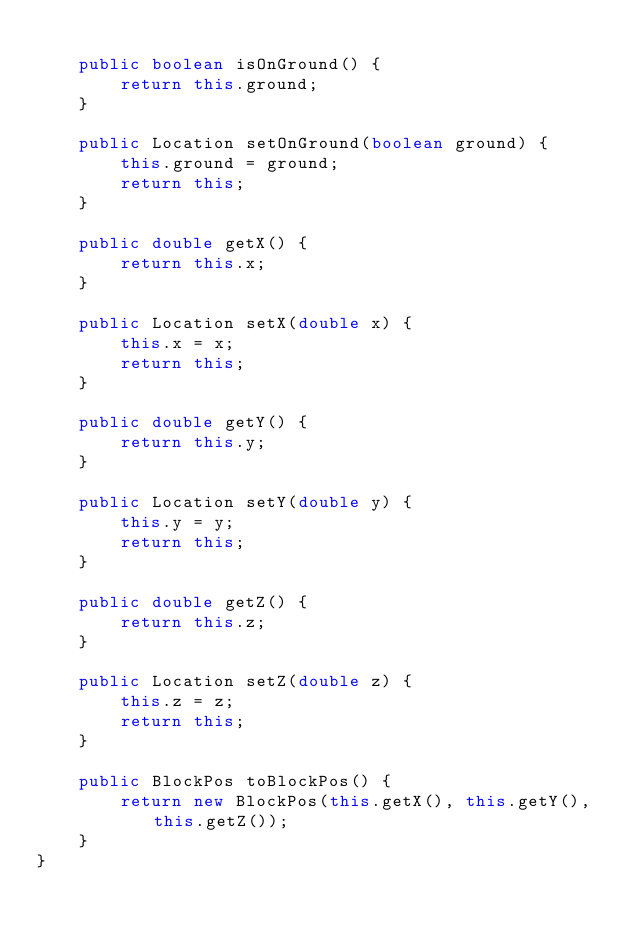<code> <loc_0><loc_0><loc_500><loc_500><_Java_>
    public boolean isOnGround() {
        return this.ground;
    }

    public Location setOnGround(boolean ground) {
        this.ground = ground;
        return this;
    }

    public double getX() {
        return this.x;
    }

    public Location setX(double x) {
        this.x = x;
        return this;
    }

    public double getY() {
        return this.y;
    }

    public Location setY(double y) {
        this.y = y;
        return this;
    }

    public double getZ() {
        return this.z;
    }

    public Location setZ(double z) {
        this.z = z;
        return this;
    }

    public BlockPos toBlockPos() {
        return new BlockPos(this.getX(), this.getY(), this.getZ());
    }
}

</code> 